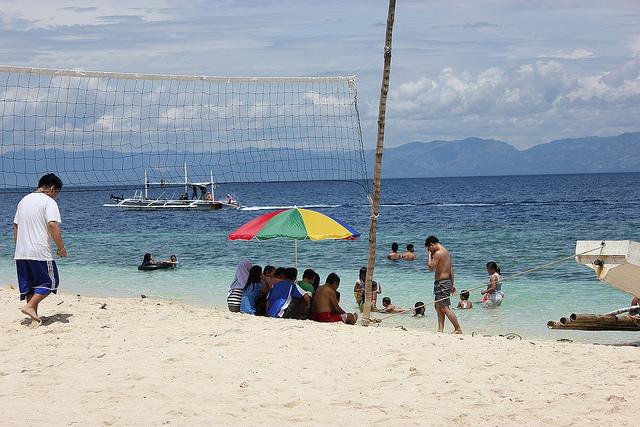What object has been pushed into the sand?
Short answer required. Umbrella. How many umbrellas do you see?
Give a very brief answer. 1. What game is being played?
Short answer required. Volleyball. Are they all together?
Quick response, please. Yes. What is the boat used for?
Be succinct. Parties. Is this man happy?
Be succinct. Yes. How many boats are in the water?
Answer briefly. 1. Are they swimming?
Answer briefly. Yes. How many umbrellas are in the picture?
Give a very brief answer. 1. Is there a volleyball net on the beach?
Concise answer only. Yes. Is the boy dressed in the white shirt with black and blue shorts wearing shoes?
Keep it brief. No. 